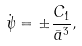Convert formula to latex. <formula><loc_0><loc_0><loc_500><loc_500>\dot { \psi } = \pm \frac { C _ { 1 } } { { \bar { a } } ^ { 3 } } ,</formula> 